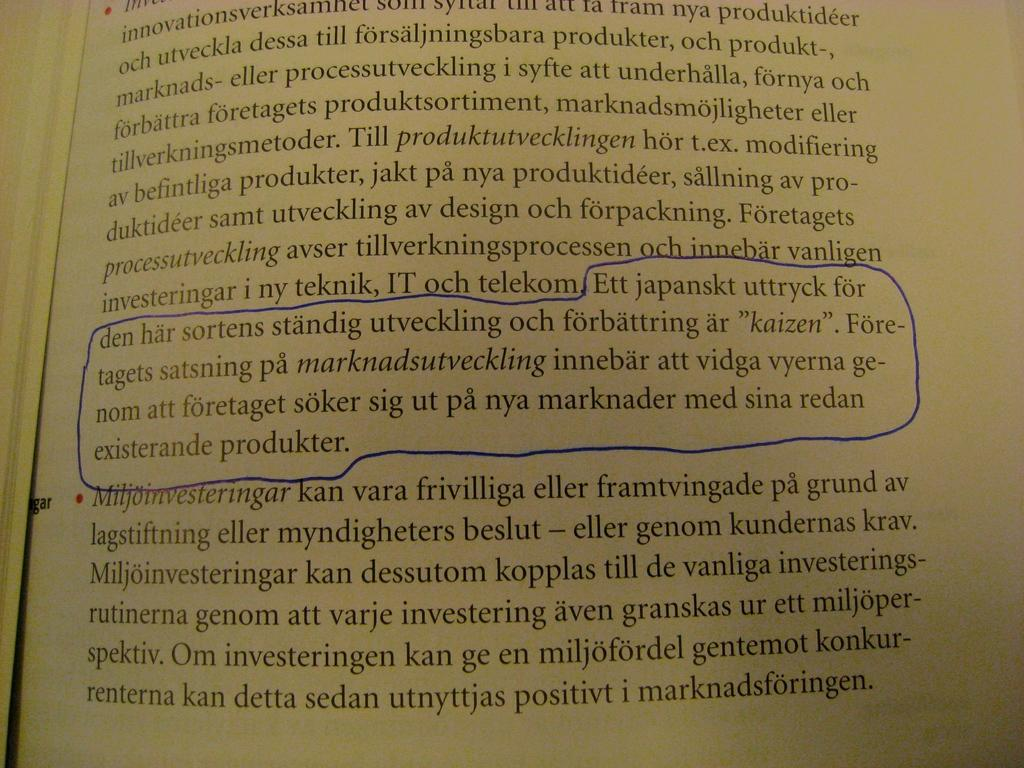<image>
Create a compact narrative representing the image presented. Ett Japanskt uttryck with a blue circle around it in a book. 